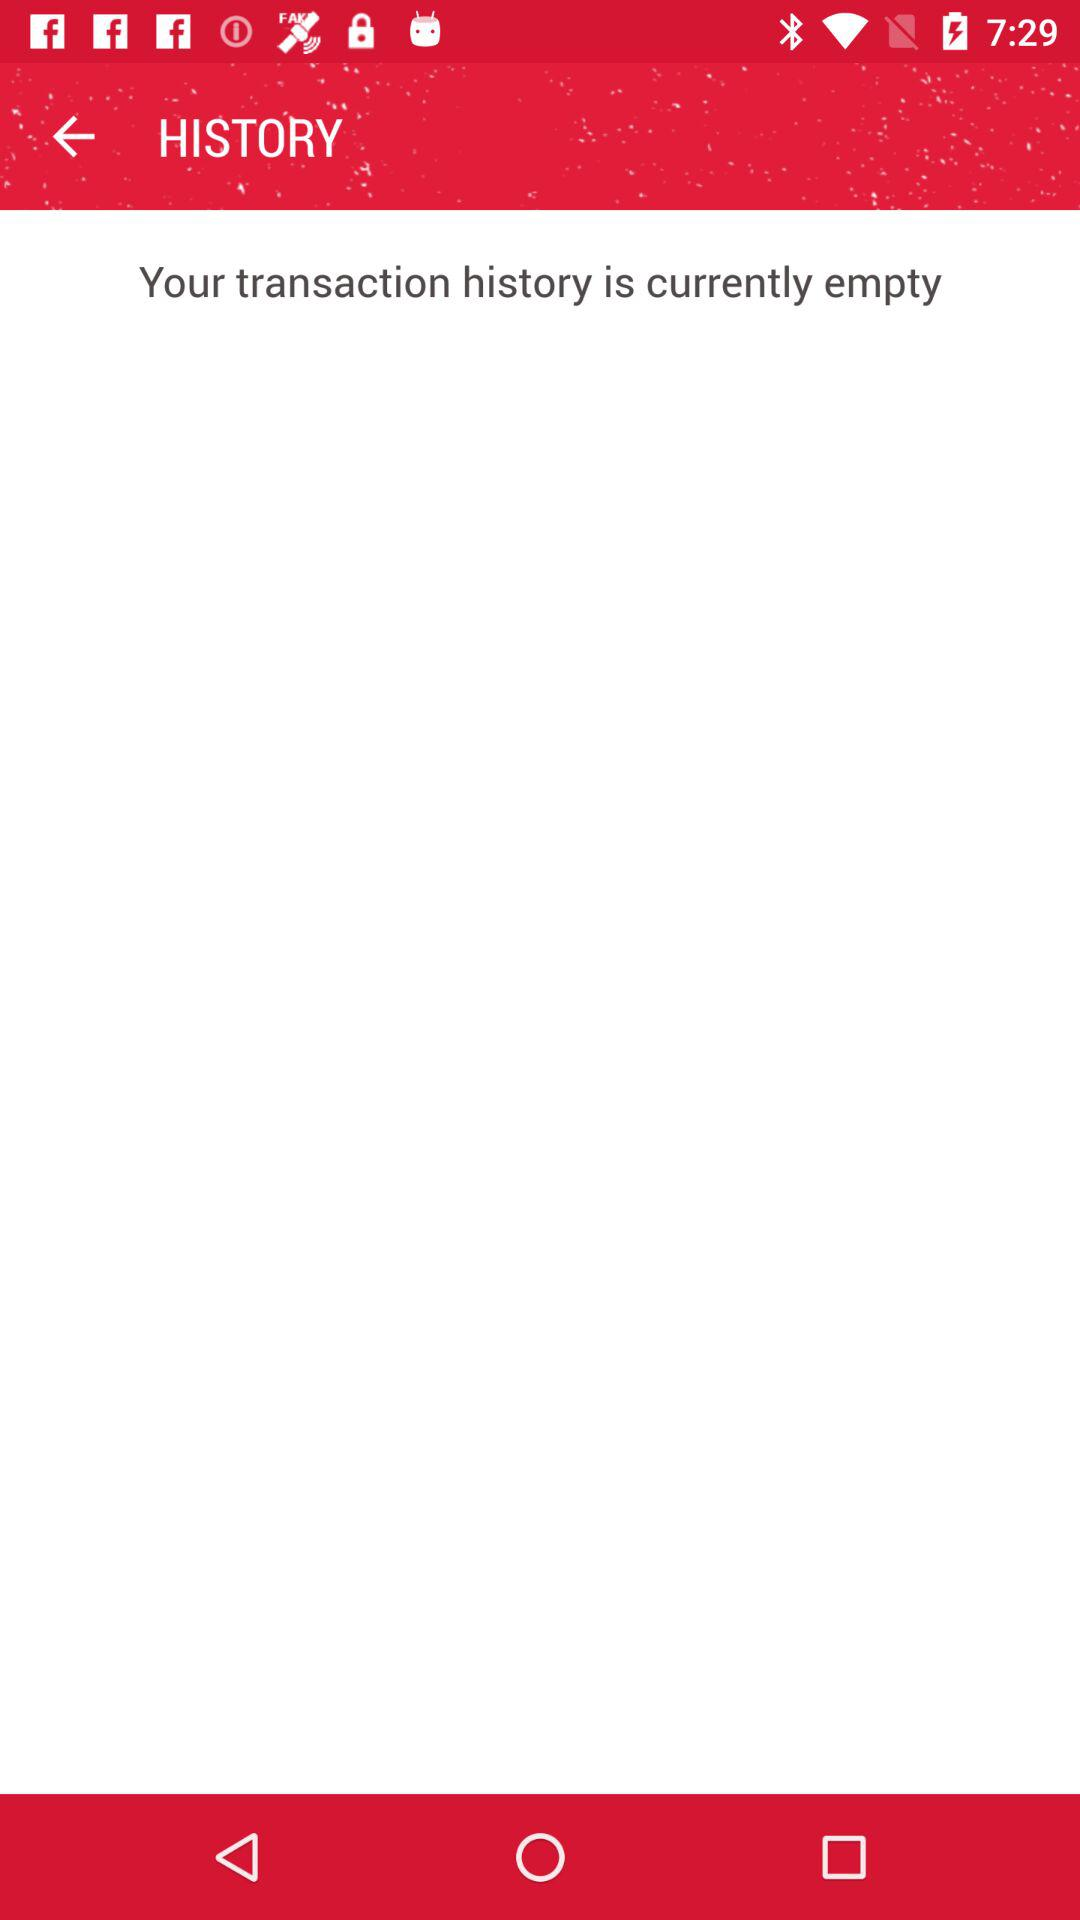Are there any transactions right now? Right now, the transaction history is empty. 